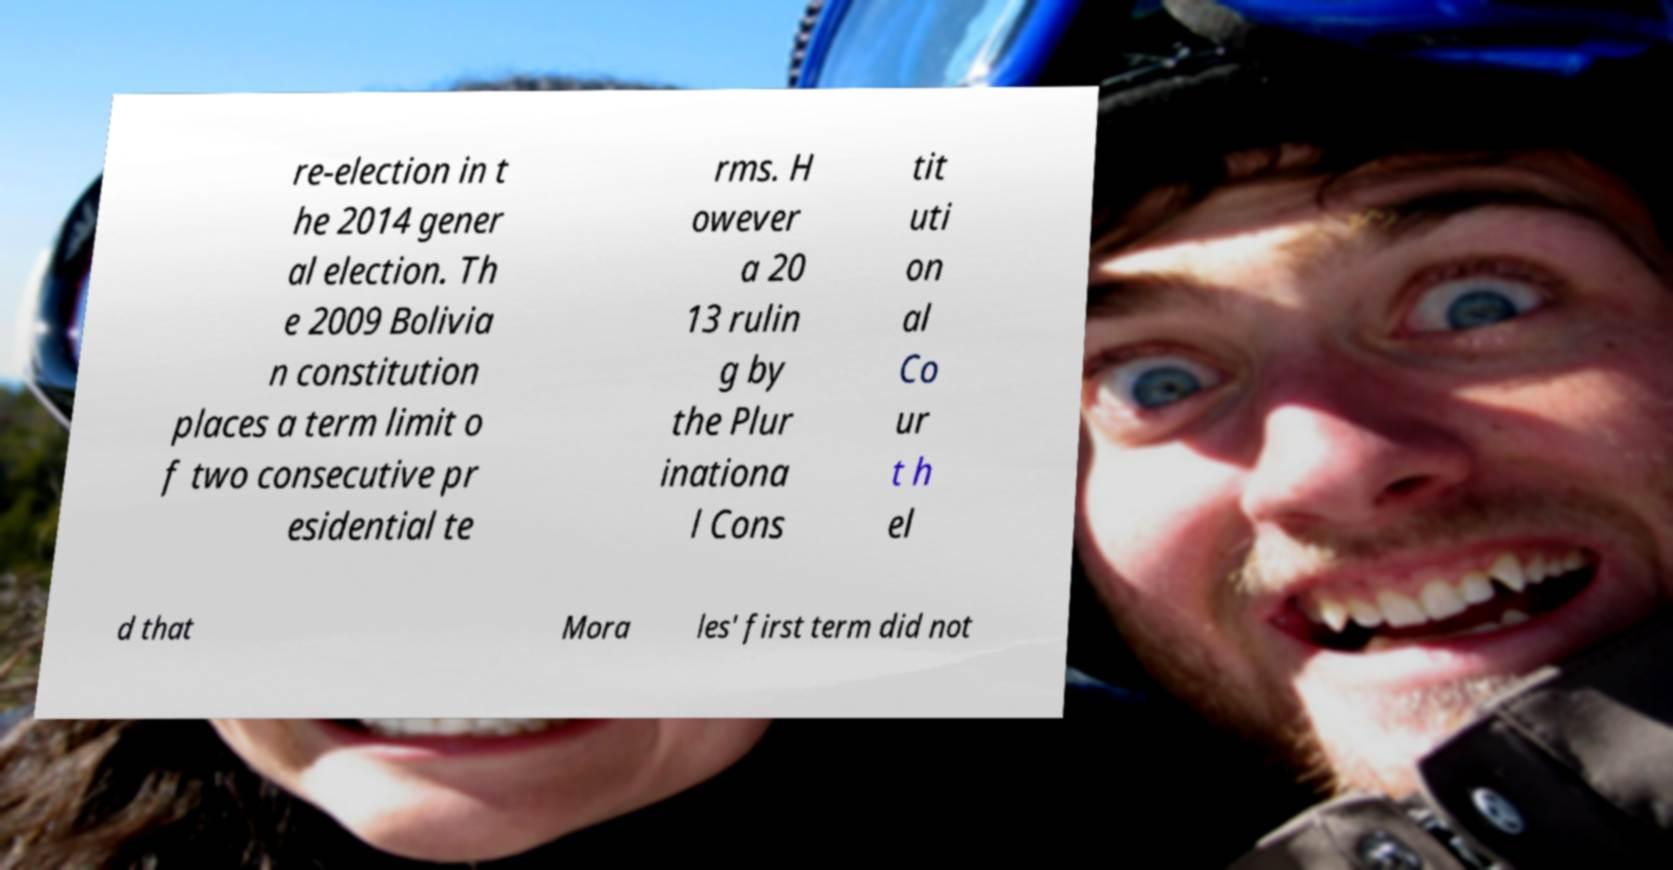I need the written content from this picture converted into text. Can you do that? re-election in t he 2014 gener al election. Th e 2009 Bolivia n constitution places a term limit o f two consecutive pr esidential te rms. H owever a 20 13 rulin g by the Plur inationa l Cons tit uti on al Co ur t h el d that Mora les' first term did not 